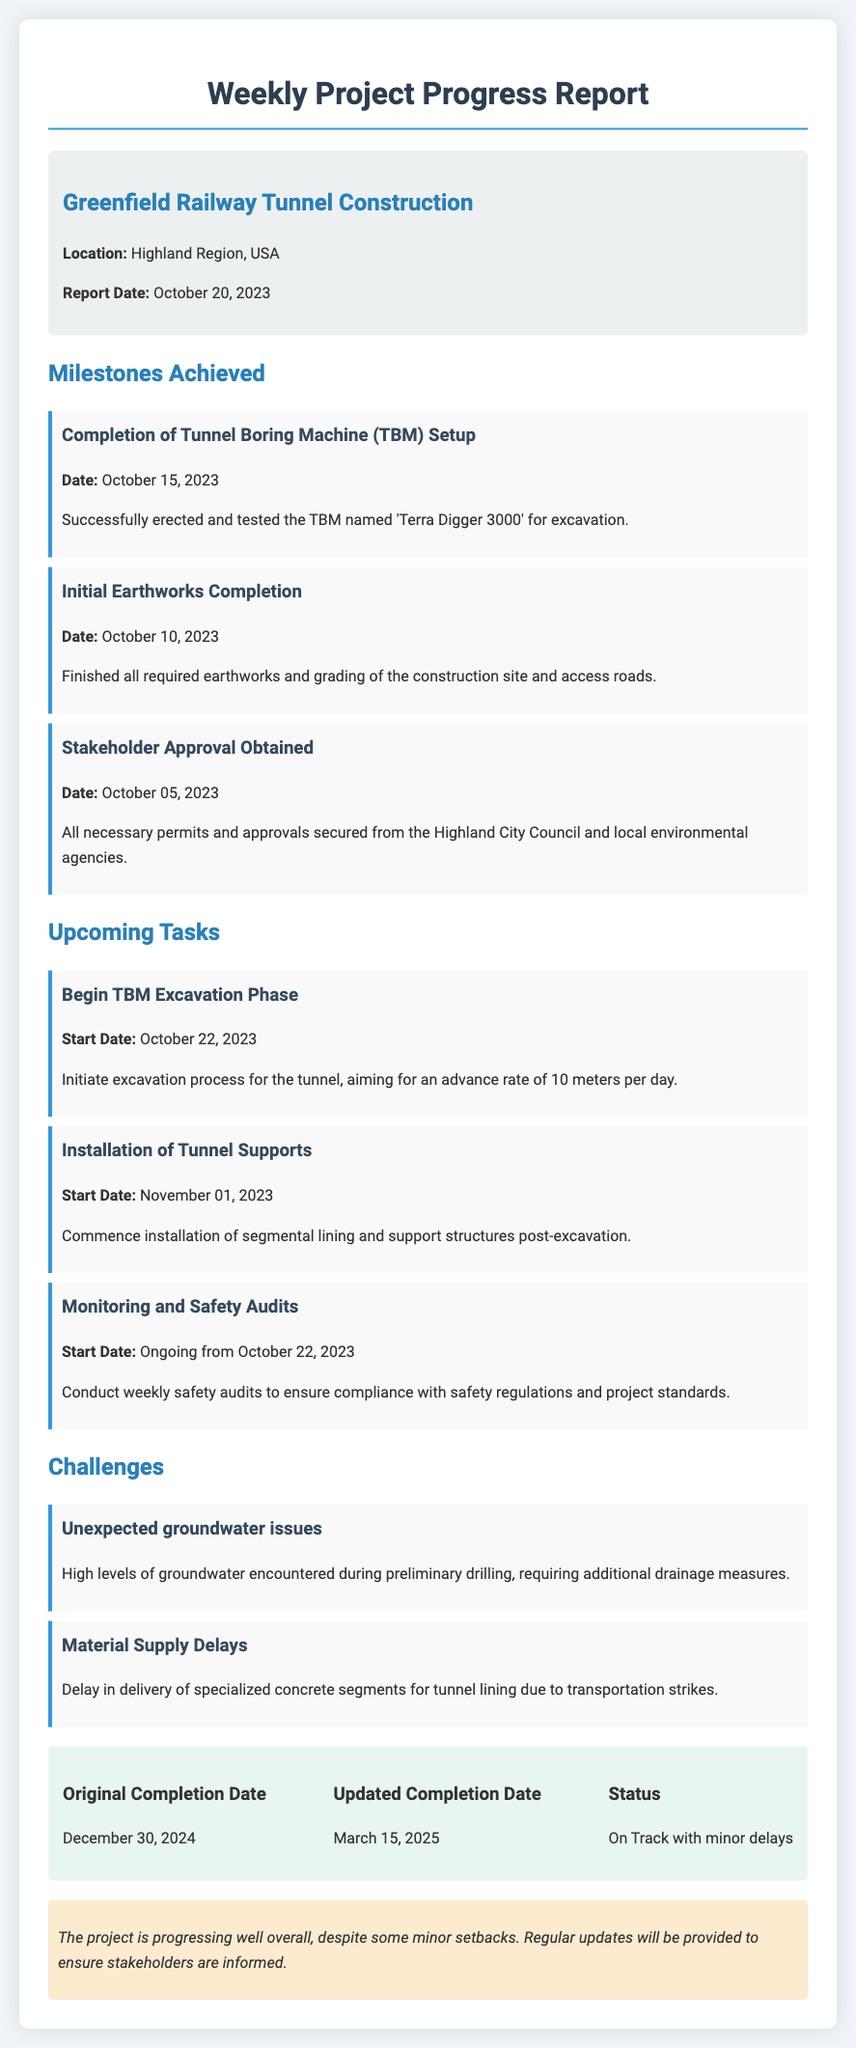What is the location of the railway tunnel construction? The document specifies that the location is in the Highland Region, USA.
Answer: Highland Region, USA When was the TBM setup completed? The document states that the TBM setup was completed on October 15, 2023.
Answer: October 15, 2023 What is the planned advance rate for TBM excavation? The planned advance rate for the TBM excavation is provided as 10 meters per day in the upcoming tasks section.
Answer: 10 meters per day What is the updated completion date of the project? The document indicates that the updated completion date is March 15, 2025.
Answer: March 15, 2025 What challenge is mentioned regarding groundwater? The document describes encountering high levels of groundwater during preliminary drilling as a challenge.
Answer: Unexpected groundwater issues How many milestones were achieved? The document lists three completed milestones in the "Milestones Achieved" section.
Answer: Three What is the start date for the installation of tunnel supports? The upcoming task section states that the installation of tunnel supports will begin on November 01, 2023.
Answer: November 01, 2023 What is the overall status of the project? The document mentions that the project's status is on track with minor delays.
Answer: On Track with minor delays What is emphasized for project updates? The "comments" section emphasizes that regular updates will be provided to ensure stakeholders are informed.
Answer: Regular updates 